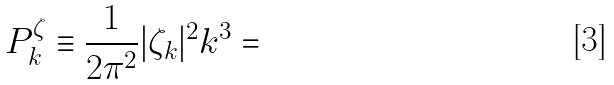<formula> <loc_0><loc_0><loc_500><loc_500>P _ { k } ^ { \zeta } \equiv \frac { 1 } { 2 \pi ^ { 2 } } | \zeta _ { k } | ^ { 2 } k ^ { 3 } =</formula> 